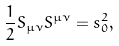Convert formula to latex. <formula><loc_0><loc_0><loc_500><loc_500>\frac { 1 } { 2 } S _ { \mu \nu } S ^ { \mu \nu } = s _ { 0 } ^ { 2 } ,</formula> 